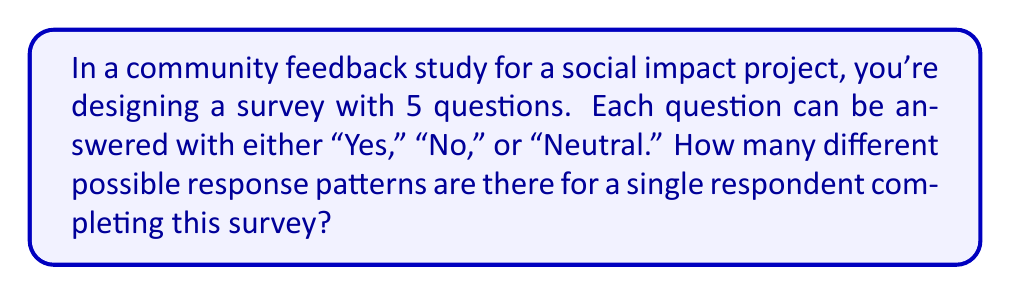Can you solve this math problem? Let's approach this step-by-step:

1) First, we need to understand what the question is asking. We're looking for the total number of possible ways a respondent can answer the 5 questions, given that each question has 3 possible answers.

2) This is a perfect scenario for using the multiplication principle of counting. The multiplication principle states that if we have a sequence of $n$ choices, and:
   - The first choice has $m_1$ options
   - The second choice has $m_2$ options
   - ...
   - The $n$-th choice has $m_n$ options

   Then the total number of possible outcomes is:

   $$ m_1 \times m_2 \times ... \times m_n $$

3) In our case:
   - We have 5 questions (so $n = 5$)
   - Each question has 3 possible answers (so $m_1 = m_2 = m_3 = m_4 = m_5 = 3$)

4) Therefore, the total number of possible response patterns is:

   $$ 3 \times 3 \times 3 \times 3 \times 3 = 3^5 $$

5) Calculate $3^5$:
   $$ 3^5 = 3 \times 3 \times 3 \times 3 \times 3 = 243 $$

Thus, there are 243 different possible response patterns for a single respondent completing this survey.
Answer: 243 